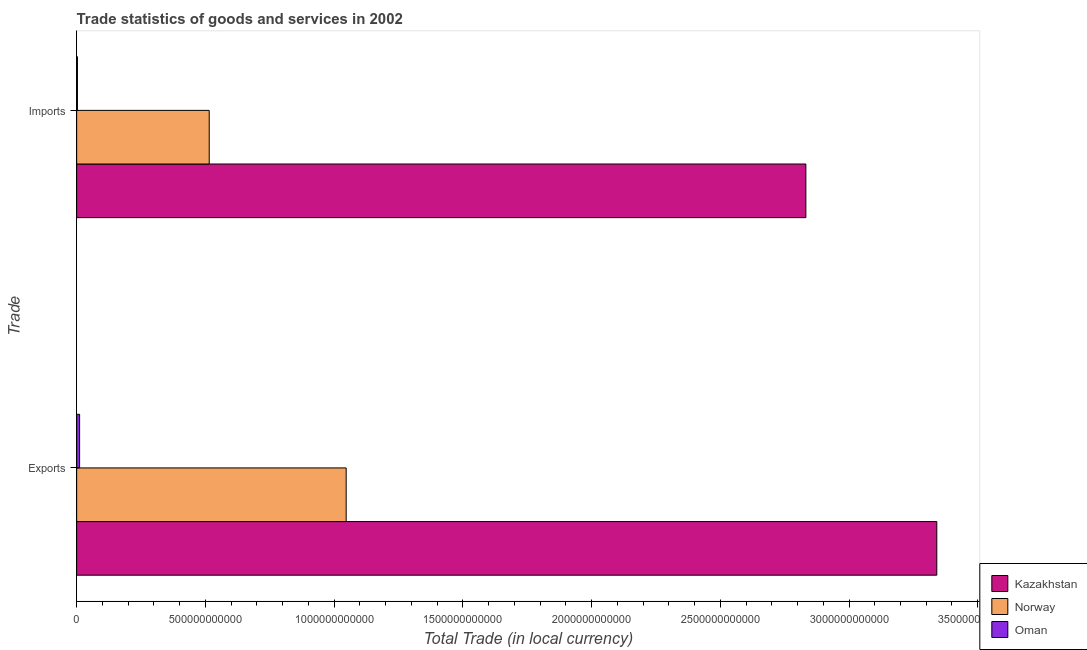How many different coloured bars are there?
Your response must be concise. 3. How many groups of bars are there?
Offer a very short reply. 2. How many bars are there on the 2nd tick from the top?
Your response must be concise. 3. How many bars are there on the 2nd tick from the bottom?
Offer a very short reply. 3. What is the label of the 2nd group of bars from the top?
Your response must be concise. Exports. What is the export of goods and services in Oman?
Provide a succinct answer. 1.14e+1. Across all countries, what is the maximum imports of goods and services?
Make the answer very short. 2.83e+12. Across all countries, what is the minimum imports of goods and services?
Offer a very short reply. 2.99e+09. In which country was the export of goods and services maximum?
Make the answer very short. Kazakhstan. In which country was the export of goods and services minimum?
Your answer should be very brief. Oman. What is the total export of goods and services in the graph?
Make the answer very short. 4.40e+12. What is the difference between the imports of goods and services in Oman and that in Kazakhstan?
Provide a succinct answer. -2.83e+12. What is the difference between the imports of goods and services in Kazakhstan and the export of goods and services in Norway?
Provide a succinct answer. 1.79e+12. What is the average imports of goods and services per country?
Provide a short and direct response. 1.12e+12. What is the difference between the imports of goods and services and export of goods and services in Oman?
Give a very brief answer. -8.46e+09. In how many countries, is the imports of goods and services greater than 400000000000 LCU?
Offer a very short reply. 2. What is the ratio of the export of goods and services in Norway to that in Kazakhstan?
Your answer should be compact. 0.31. Is the export of goods and services in Oman less than that in Kazakhstan?
Make the answer very short. Yes. In how many countries, is the export of goods and services greater than the average export of goods and services taken over all countries?
Keep it short and to the point. 1. What does the 3rd bar from the top in Exports represents?
Your answer should be very brief. Kazakhstan. What does the 1st bar from the bottom in Imports represents?
Make the answer very short. Kazakhstan. How many countries are there in the graph?
Keep it short and to the point. 3. What is the difference between two consecutive major ticks on the X-axis?
Ensure brevity in your answer.  5.00e+11. Where does the legend appear in the graph?
Give a very brief answer. Bottom right. What is the title of the graph?
Your answer should be compact. Trade statistics of goods and services in 2002. Does "Bahamas" appear as one of the legend labels in the graph?
Provide a succinct answer. No. What is the label or title of the X-axis?
Provide a succinct answer. Total Trade (in local currency). What is the label or title of the Y-axis?
Give a very brief answer. Trade. What is the Total Trade (in local currency) of Kazakhstan in Exports?
Provide a succinct answer. 3.34e+12. What is the Total Trade (in local currency) of Norway in Exports?
Your answer should be compact. 1.05e+12. What is the Total Trade (in local currency) in Oman in Exports?
Provide a succinct answer. 1.14e+1. What is the Total Trade (in local currency) of Kazakhstan in Imports?
Offer a very short reply. 2.83e+12. What is the Total Trade (in local currency) in Norway in Imports?
Provide a succinct answer. 5.15e+11. What is the Total Trade (in local currency) in Oman in Imports?
Make the answer very short. 2.99e+09. Across all Trade, what is the maximum Total Trade (in local currency) in Kazakhstan?
Offer a very short reply. 3.34e+12. Across all Trade, what is the maximum Total Trade (in local currency) in Norway?
Offer a terse response. 1.05e+12. Across all Trade, what is the maximum Total Trade (in local currency) of Oman?
Provide a short and direct response. 1.14e+1. Across all Trade, what is the minimum Total Trade (in local currency) of Kazakhstan?
Your answer should be compact. 2.83e+12. Across all Trade, what is the minimum Total Trade (in local currency) in Norway?
Offer a terse response. 5.15e+11. Across all Trade, what is the minimum Total Trade (in local currency) of Oman?
Keep it short and to the point. 2.99e+09. What is the total Total Trade (in local currency) of Kazakhstan in the graph?
Keep it short and to the point. 6.17e+12. What is the total Total Trade (in local currency) in Norway in the graph?
Provide a short and direct response. 1.56e+12. What is the total Total Trade (in local currency) of Oman in the graph?
Ensure brevity in your answer.  1.44e+1. What is the difference between the Total Trade (in local currency) of Kazakhstan in Exports and that in Imports?
Your response must be concise. 5.09e+11. What is the difference between the Total Trade (in local currency) in Norway in Exports and that in Imports?
Offer a very short reply. 5.32e+11. What is the difference between the Total Trade (in local currency) in Oman in Exports and that in Imports?
Your response must be concise. 8.46e+09. What is the difference between the Total Trade (in local currency) of Kazakhstan in Exports and the Total Trade (in local currency) of Norway in Imports?
Offer a terse response. 2.83e+12. What is the difference between the Total Trade (in local currency) in Kazakhstan in Exports and the Total Trade (in local currency) in Oman in Imports?
Make the answer very short. 3.34e+12. What is the difference between the Total Trade (in local currency) in Norway in Exports and the Total Trade (in local currency) in Oman in Imports?
Give a very brief answer. 1.04e+12. What is the average Total Trade (in local currency) in Kazakhstan per Trade?
Provide a short and direct response. 3.09e+12. What is the average Total Trade (in local currency) in Norway per Trade?
Give a very brief answer. 7.81e+11. What is the average Total Trade (in local currency) of Oman per Trade?
Offer a very short reply. 7.21e+09. What is the difference between the Total Trade (in local currency) of Kazakhstan and Total Trade (in local currency) of Norway in Exports?
Your answer should be compact. 2.29e+12. What is the difference between the Total Trade (in local currency) in Kazakhstan and Total Trade (in local currency) in Oman in Exports?
Provide a short and direct response. 3.33e+12. What is the difference between the Total Trade (in local currency) in Norway and Total Trade (in local currency) in Oman in Exports?
Provide a succinct answer. 1.04e+12. What is the difference between the Total Trade (in local currency) in Kazakhstan and Total Trade (in local currency) in Norway in Imports?
Offer a terse response. 2.32e+12. What is the difference between the Total Trade (in local currency) of Kazakhstan and Total Trade (in local currency) of Oman in Imports?
Make the answer very short. 2.83e+12. What is the difference between the Total Trade (in local currency) of Norway and Total Trade (in local currency) of Oman in Imports?
Your response must be concise. 5.12e+11. What is the ratio of the Total Trade (in local currency) of Kazakhstan in Exports to that in Imports?
Offer a very short reply. 1.18. What is the ratio of the Total Trade (in local currency) of Norway in Exports to that in Imports?
Your answer should be very brief. 2.03. What is the ratio of the Total Trade (in local currency) in Oman in Exports to that in Imports?
Your response must be concise. 3.83. What is the difference between the highest and the second highest Total Trade (in local currency) of Kazakhstan?
Provide a short and direct response. 5.09e+11. What is the difference between the highest and the second highest Total Trade (in local currency) in Norway?
Offer a very short reply. 5.32e+11. What is the difference between the highest and the second highest Total Trade (in local currency) in Oman?
Provide a short and direct response. 8.46e+09. What is the difference between the highest and the lowest Total Trade (in local currency) in Kazakhstan?
Give a very brief answer. 5.09e+11. What is the difference between the highest and the lowest Total Trade (in local currency) of Norway?
Ensure brevity in your answer.  5.32e+11. What is the difference between the highest and the lowest Total Trade (in local currency) in Oman?
Provide a succinct answer. 8.46e+09. 